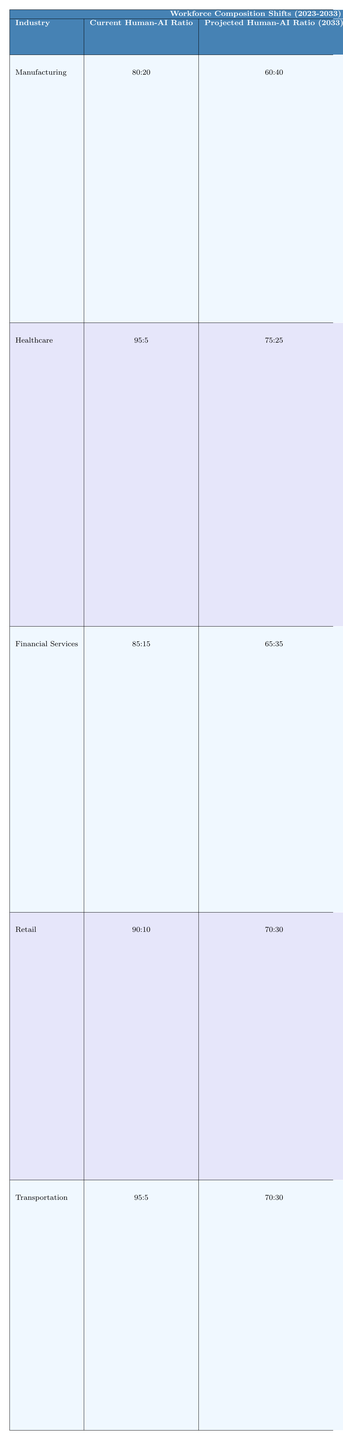What is the current human-AI ratio in the healthcare industry? In the table, the healthcare industry shows a current human-AI ratio of 95:5.
Answer: 95:5 What role in the retail industry has the highest projected reduction percentage? The table indicates that cashiers in the retail industry have a projected reduction percentage of 50%, which is higher than other roles listed.
Answer: Cashiers How many total roles are identified as affected in the manufacturing industry? In the manufacturing section, there are two listed roles: Assembly Line Workers and Quality Control Inspectors, making a total of two affected roles.
Answer: 2 Which industry is projected to have the highest human-AI ratio in 2033? By comparing the projected human-AI ratios in the table, healthcare with a ratio of 75:25 will have the highest ratio in 2033 among the industries listed.
Answer: Healthcare For financial services, what is the total projected reduction percentage for Customer Service Representatives and Financial Analysts combined? The projected reduction for Customer Service Representatives is 45% and for Financial Analysts is 25%. Adding them together gives 45 + 25 = 70%.
Answer: 70% Is there a significant difference in projected reduction percentages between assembly line workers and cashiers? Assembly line workers have a projected reduction of 35%, while cashiers have a 50% reduction. The difference is 50% - 35% = 15%, indicating a notable difference.
Answer: Yes What is the ratio of projected human-AI integration in retail compared to transportation by 2033? The projected human-AI ratios for retail and transportation in 2033 are 70:30 and 70:30, respectively. Both ratios are the same.
Answer: They are the same (70:30) How does the change in the healthcare industry human-AI ratio from 2023 to 2033 compare to that in manufacturing? The healthcare ratio changes from 95:5 to 75:25, whereas manufacturing changes from 80:20 to 60:40. Both industries experience a reduction, but healthcare has a larger total ratio change of 20% compared to 20% in manufacturing, indicating equal impact.
Answer: They have equal impacts Which roles are emerging in the transportation industry due to AI integration? The table lists two emerging roles in transportation: Autonomous Vehicle Supervisors and Fleet AI System Managers as a result of AI integration affecting truck drivers and logistics coordinators.
Answer: Autonomous Vehicle Supervisors, Fleet AI System Managers If we consider all affected roles across all industries, which role has the lowest projected reduction percentage? Scanning through all affected roles, Pharmacists in the healthcare industry have the lowest projected reduction at 20%.
Answer: Pharmacists 